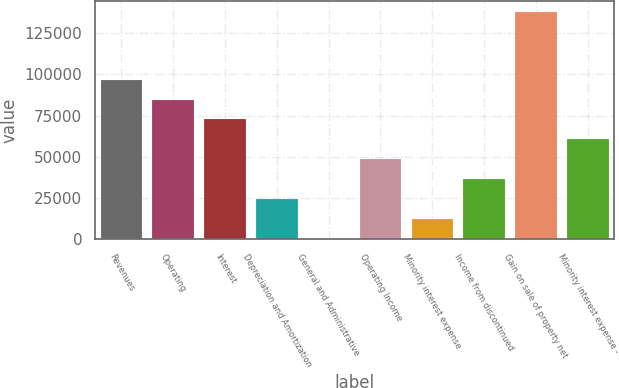<chart> <loc_0><loc_0><loc_500><loc_500><bar_chart><fcel>Revenues<fcel>Operating<fcel>Interest<fcel>Depreciation and Amortization<fcel>General and Administrative<fcel>Operating Income<fcel>Minority interest expense<fcel>Income from discontinued<fcel>Gain on sale of property net<fcel>Minority interest expense -<nl><fcel>96867<fcel>84764.5<fcel>72662<fcel>24252<fcel>47<fcel>48457<fcel>12149.5<fcel>36354.5<fcel>137770<fcel>60559.5<nl></chart> 